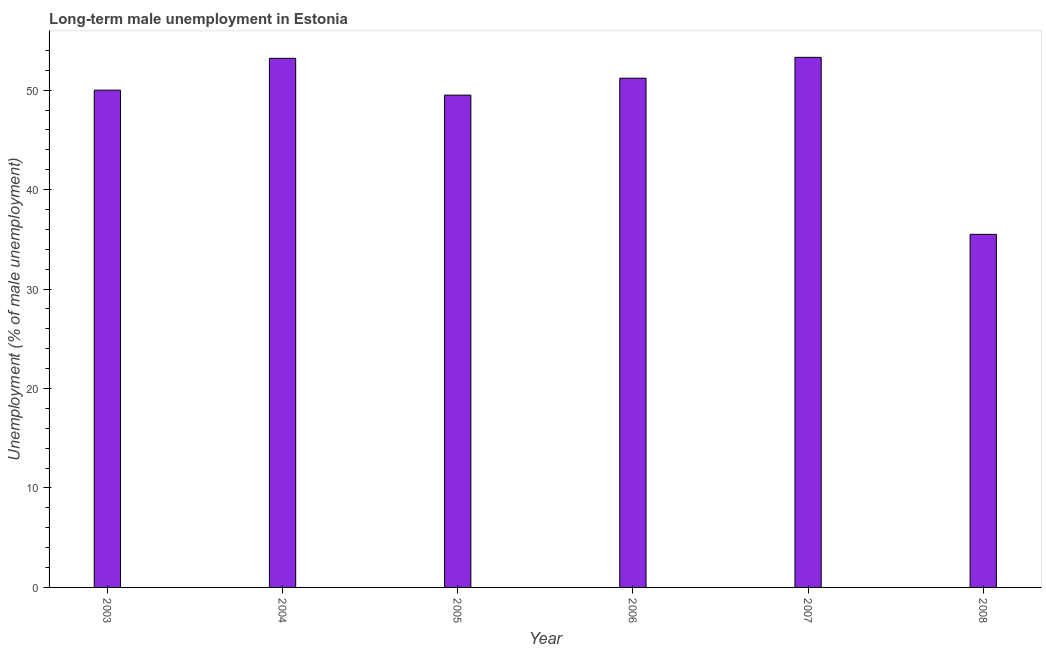Does the graph contain any zero values?
Give a very brief answer. No. What is the title of the graph?
Provide a succinct answer. Long-term male unemployment in Estonia. What is the label or title of the X-axis?
Offer a very short reply. Year. What is the label or title of the Y-axis?
Give a very brief answer. Unemployment (% of male unemployment). What is the long-term male unemployment in 2006?
Provide a succinct answer. 51.2. Across all years, what is the maximum long-term male unemployment?
Ensure brevity in your answer.  53.3. Across all years, what is the minimum long-term male unemployment?
Make the answer very short. 35.5. What is the sum of the long-term male unemployment?
Provide a short and direct response. 292.7. What is the average long-term male unemployment per year?
Your answer should be compact. 48.78. What is the median long-term male unemployment?
Your response must be concise. 50.6. Do a majority of the years between 2007 and 2004 (inclusive) have long-term male unemployment greater than 24 %?
Give a very brief answer. Yes. What is the ratio of the long-term male unemployment in 2003 to that in 2008?
Give a very brief answer. 1.41. Is the difference between the long-term male unemployment in 2007 and 2008 greater than the difference between any two years?
Provide a succinct answer. Yes. Is the sum of the long-term male unemployment in 2003 and 2008 greater than the maximum long-term male unemployment across all years?
Provide a short and direct response. Yes. How many bars are there?
Offer a very short reply. 6. Are all the bars in the graph horizontal?
Offer a terse response. No. How many years are there in the graph?
Keep it short and to the point. 6. What is the difference between two consecutive major ticks on the Y-axis?
Your response must be concise. 10. What is the Unemployment (% of male unemployment) in 2003?
Offer a terse response. 50. What is the Unemployment (% of male unemployment) of 2004?
Ensure brevity in your answer.  53.2. What is the Unemployment (% of male unemployment) in 2005?
Ensure brevity in your answer.  49.5. What is the Unemployment (% of male unemployment) of 2006?
Give a very brief answer. 51.2. What is the Unemployment (% of male unemployment) in 2007?
Offer a very short reply. 53.3. What is the Unemployment (% of male unemployment) in 2008?
Ensure brevity in your answer.  35.5. What is the difference between the Unemployment (% of male unemployment) in 2003 and 2004?
Ensure brevity in your answer.  -3.2. What is the difference between the Unemployment (% of male unemployment) in 2003 and 2006?
Keep it short and to the point. -1.2. What is the difference between the Unemployment (% of male unemployment) in 2003 and 2007?
Provide a short and direct response. -3.3. What is the difference between the Unemployment (% of male unemployment) in 2003 and 2008?
Your response must be concise. 14.5. What is the difference between the Unemployment (% of male unemployment) in 2004 and 2007?
Offer a very short reply. -0.1. What is the difference between the Unemployment (% of male unemployment) in 2005 and 2008?
Give a very brief answer. 14. What is the difference between the Unemployment (% of male unemployment) in 2006 and 2007?
Offer a terse response. -2.1. What is the difference between the Unemployment (% of male unemployment) in 2006 and 2008?
Provide a short and direct response. 15.7. What is the ratio of the Unemployment (% of male unemployment) in 2003 to that in 2005?
Provide a succinct answer. 1.01. What is the ratio of the Unemployment (% of male unemployment) in 2003 to that in 2006?
Keep it short and to the point. 0.98. What is the ratio of the Unemployment (% of male unemployment) in 2003 to that in 2007?
Offer a terse response. 0.94. What is the ratio of the Unemployment (% of male unemployment) in 2003 to that in 2008?
Give a very brief answer. 1.41. What is the ratio of the Unemployment (% of male unemployment) in 2004 to that in 2005?
Ensure brevity in your answer.  1.07. What is the ratio of the Unemployment (% of male unemployment) in 2004 to that in 2006?
Give a very brief answer. 1.04. What is the ratio of the Unemployment (% of male unemployment) in 2004 to that in 2008?
Your response must be concise. 1.5. What is the ratio of the Unemployment (% of male unemployment) in 2005 to that in 2006?
Make the answer very short. 0.97. What is the ratio of the Unemployment (% of male unemployment) in 2005 to that in 2007?
Give a very brief answer. 0.93. What is the ratio of the Unemployment (% of male unemployment) in 2005 to that in 2008?
Your response must be concise. 1.39. What is the ratio of the Unemployment (% of male unemployment) in 2006 to that in 2007?
Offer a very short reply. 0.96. What is the ratio of the Unemployment (% of male unemployment) in 2006 to that in 2008?
Keep it short and to the point. 1.44. What is the ratio of the Unemployment (% of male unemployment) in 2007 to that in 2008?
Give a very brief answer. 1.5. 